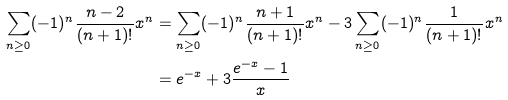<formula> <loc_0><loc_0><loc_500><loc_500>\sum _ { n \geq 0 } ( - 1 ) ^ { n } \frac { n - 2 } { ( n + 1 ) ! } x ^ { n } & = \sum _ { n \geq 0 } ( - 1 ) ^ { n } \frac { n + 1 } { ( n + 1 ) ! } x ^ { n } - 3 \sum _ { n \geq 0 } ( - 1 ) ^ { n } \frac { 1 } { ( n + 1 ) ! } x ^ { n } \\ & = e ^ { - x } + 3 \frac { e ^ { - x } - 1 } { x }</formula> 